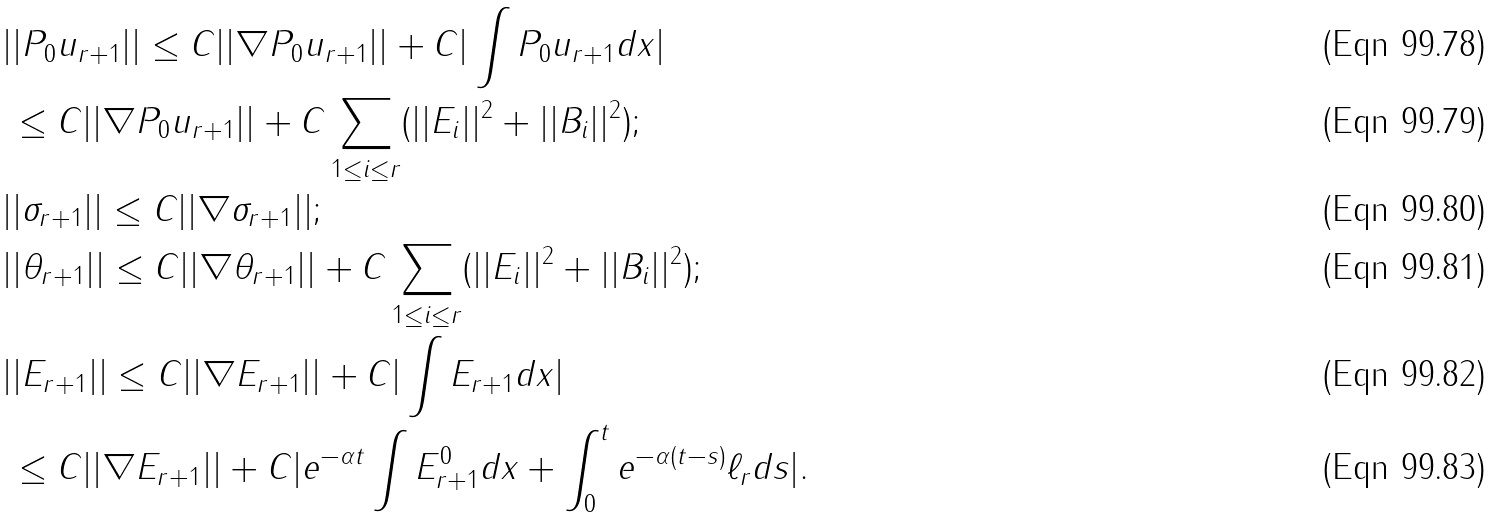<formula> <loc_0><loc_0><loc_500><loc_500>& | | P _ { 0 } u _ { r + 1 } | | \leq C | | \nabla P _ { 0 } u _ { r + 1 } | | + C | \int P _ { 0 } u _ { r + 1 } d x | \\ & \, \leq C | | \nabla P _ { 0 } u _ { r + 1 } | | + C \sum _ { 1 \leq i \leq r } ( | | E _ { i } | | ^ { 2 } + | | B _ { i } | | ^ { 2 } ) ; \\ & | | \sigma _ { r + 1 } | | \leq C | | \nabla \sigma _ { r + 1 } | | ; \\ & | | \theta _ { r + 1 } | | \leq C | | \nabla \theta _ { r + 1 } | | + C \sum _ { 1 \leq i \leq r } ( | | E _ { i } | | ^ { 2 } + | | B _ { i } | | ^ { 2 } ) ; \\ & | | E _ { r + 1 } | | \leq C | | \nabla E _ { r + 1 } | | + C | \int E _ { r + 1 } d x | \\ & \, \leq C | | \nabla E _ { r + 1 } | | + C | e ^ { - \alpha t } \int E _ { r + 1 } ^ { 0 } d x + \int _ { 0 } ^ { t } e ^ { - \alpha ( t - s ) } \ell _ { r } d s | .</formula> 